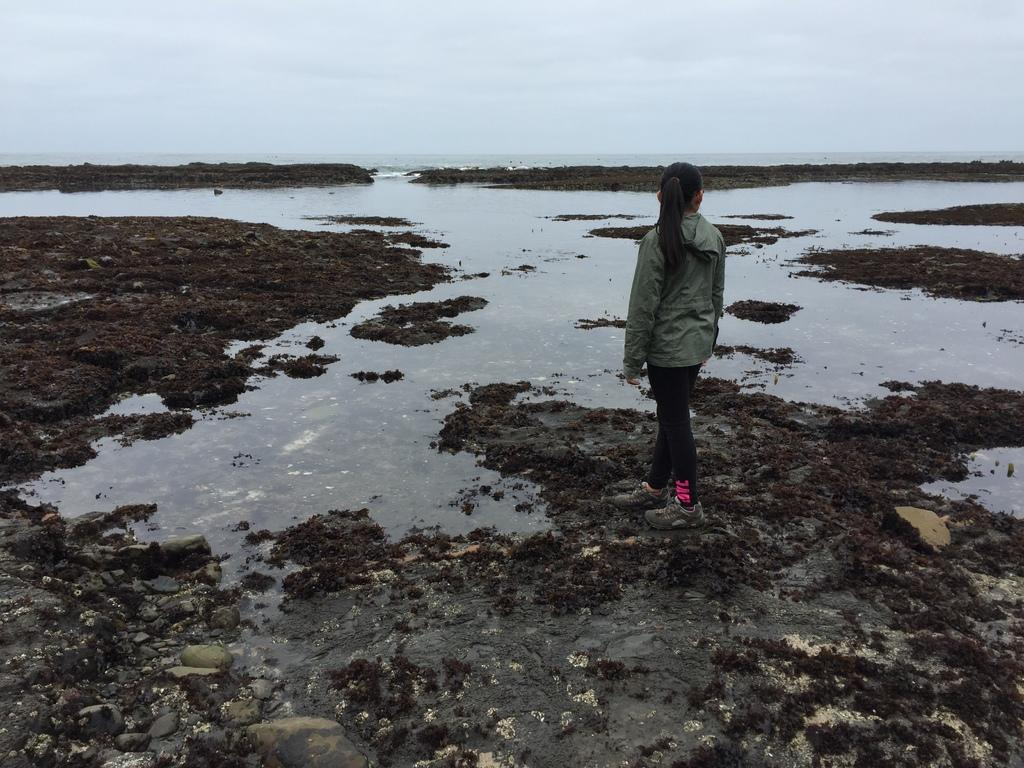Who or what is the main subject in the image? There is a person in the image. What is the person wearing? The person is wearing a jacket. Where is the person standing? The person is standing on a lake. What can be seen in the background of the image? There is a sky visible in the background of the image. What type of train can be seen in the background of the image? There is no train present in the image; the person is standing on a lake with a sky visible in the background. 